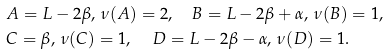<formula> <loc_0><loc_0><loc_500><loc_500>& A = L - 2 \beta , \, \nu ( A ) = 2 , \quad B = L - 2 \beta + \alpha , \, \nu ( B ) = 1 , \\ & C = \beta , \, \nu ( C ) = 1 , \quad \, D = L - 2 \beta - \alpha , \, \nu ( D ) = 1 .</formula> 